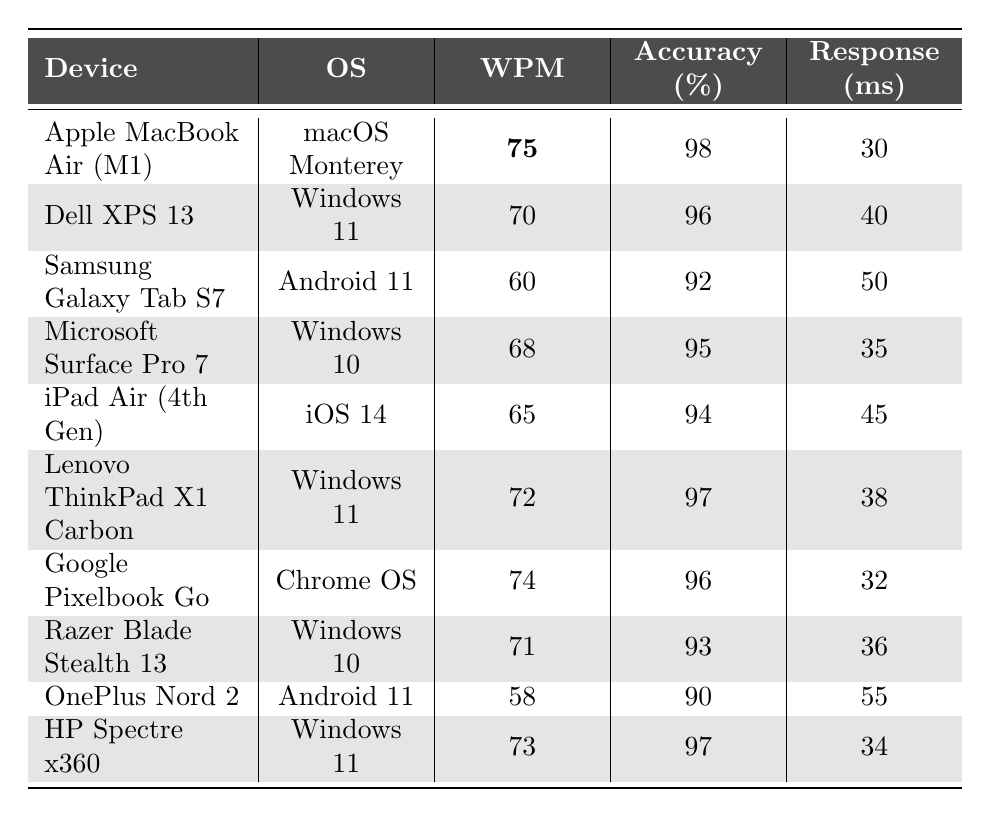What is the words per minute (WPM) for the Apple MacBook Air (M1)? The table shows that the words per minute for the Apple MacBook Air (M1) is listed directly as 75.
Answer: 75 Which device has the highest accuracy percentage? The accuracy percentages in the table must be compared; the maximum value seen is 98% for the Apple MacBook Air (M1).
Answer: Apple MacBook Air (M1) What is the difference in words per minute between the Dell XPS 13 and the iPad Air (4th Gen)? The WPM of the Dell XPS 13 is 70 and the iPad Air (4th Gen) is 65. The difference is 70 - 65 = 5 WPM.
Answer: 5 What is the average response time across all devices? The response times are 30, 40, 50, 35, 45, 38, 32, 36, 55, and 34 ms. Adding these (30 + 40 + 50 + 35 + 45 + 38 + 32 + 36 + 55 + 34 =  415) gives 415. Dividing by the 10 devices gives an average response time of 415/10 = 41.5 ms.
Answer: 41.5 ms Is the accuracy percentage lower for devices running Android compared to devices running Windows 11? The accuracy percentage for Samsung Galaxy Tab S7 (Android) is 92% and for OnePlus Nord 2 (Android) is 90%. For Windows 11, Dell XPS 13 is 96%, Lenovo ThinkPad X1 Carbon and HP Spectre x360 are 97%. So the averages are 91% for Android and 96% for Windows 11 indicating that Windows 11 devices have higher accuracy.
Answer: Yes, Windows 11 devices have higher accuracy Which device has the lowest words per minute and what is that value? The OnePlus Nord 2 has the lowest WPM, which is explicitly listed in the table as 58.
Answer: 58 How many devices have a response time of 35 ms or less? From the table, two devices meet this criterion: Apple MacBook Air (M1) at 30 ms and HP Spectre x360 at 34 ms. Thus, the total count is 2.
Answer: 2 What is the median words per minute of all devices? To find the median, list the WPM values in ascending order: 58, 60, 65, 68, 70, 71, 72, 73, 74, 75. The median is the average of the 5th and 6th values: (70 + 71)/2 = 70.5.
Answer: 70.5 If we consider only the devices with an operating system of Windows, what is the average accuracy percentage? For Windows devices, the accuracy percentages are 96%, 95%, 97%, 93%, and 97%. Adding these gives 478. Dividing by 5 (the number of devices) gives an average of 478/5 = 95.6%.
Answer: 95.6% Which device responds faster, the Razer Blade Stealth 13 or the Lenovo ThinkPad X1 Carbon? The Razer Blade Stealth 13 has a response time of 36 ms and Lenovo ThinkPad X1 Carbon has 38 ms; comparing these, 36 ms is faster than 38 ms.
Answer: Razer Blade Stealth 13 